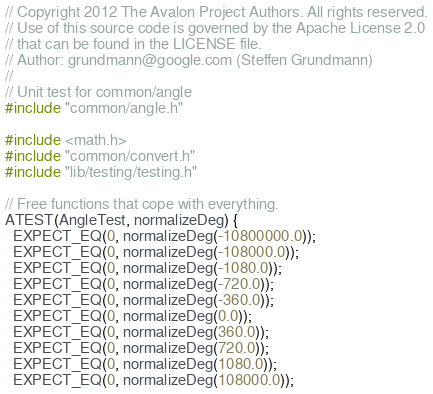Convert code to text. <code><loc_0><loc_0><loc_500><loc_500><_C++_>// Copyright 2012 The Avalon Project Authors. All rights reserved.
// Use of this source code is governed by the Apache License 2.0
// that can be found in the LICENSE file.
// Author: grundmann@google.com (Steffen Grundmann)
//
// Unit test for common/angle
#include "common/angle.h"

#include <math.h>
#include "common/convert.h"
#include "lib/testing/testing.h"

// Free functions that cope with everything.
ATEST(AngleTest, normalizeDeg) {
  EXPECT_EQ(0, normalizeDeg(-10800000.0));
  EXPECT_EQ(0, normalizeDeg(-108000.0));
  EXPECT_EQ(0, normalizeDeg(-1080.0));
  EXPECT_EQ(0, normalizeDeg(-720.0));
  EXPECT_EQ(0, normalizeDeg(-360.0));
  EXPECT_EQ(0, normalizeDeg(0.0));
  EXPECT_EQ(0, normalizeDeg(360.0));
  EXPECT_EQ(0, normalizeDeg(720.0));
  EXPECT_EQ(0, normalizeDeg(1080.0));
  EXPECT_EQ(0, normalizeDeg(108000.0));</code> 